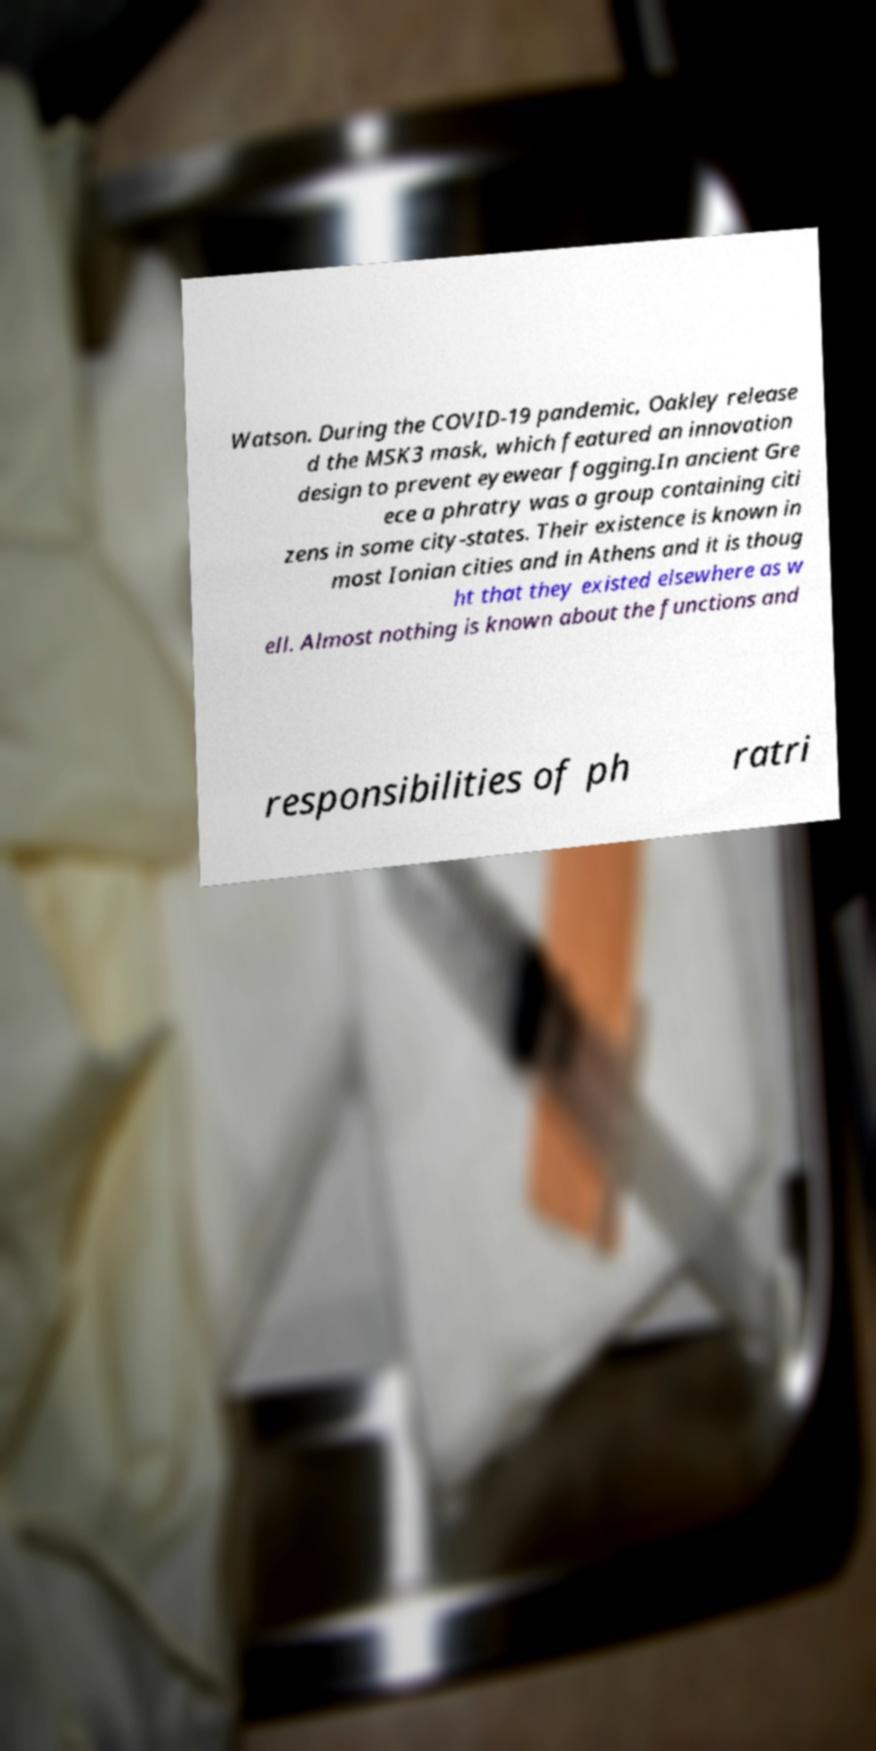Please read and relay the text visible in this image. What does it say? Watson. During the COVID-19 pandemic, Oakley release d the MSK3 mask, which featured an innovation design to prevent eyewear fogging.In ancient Gre ece a phratry was a group containing citi zens in some city-states. Their existence is known in most Ionian cities and in Athens and it is thoug ht that they existed elsewhere as w ell. Almost nothing is known about the functions and responsibilities of ph ratri 